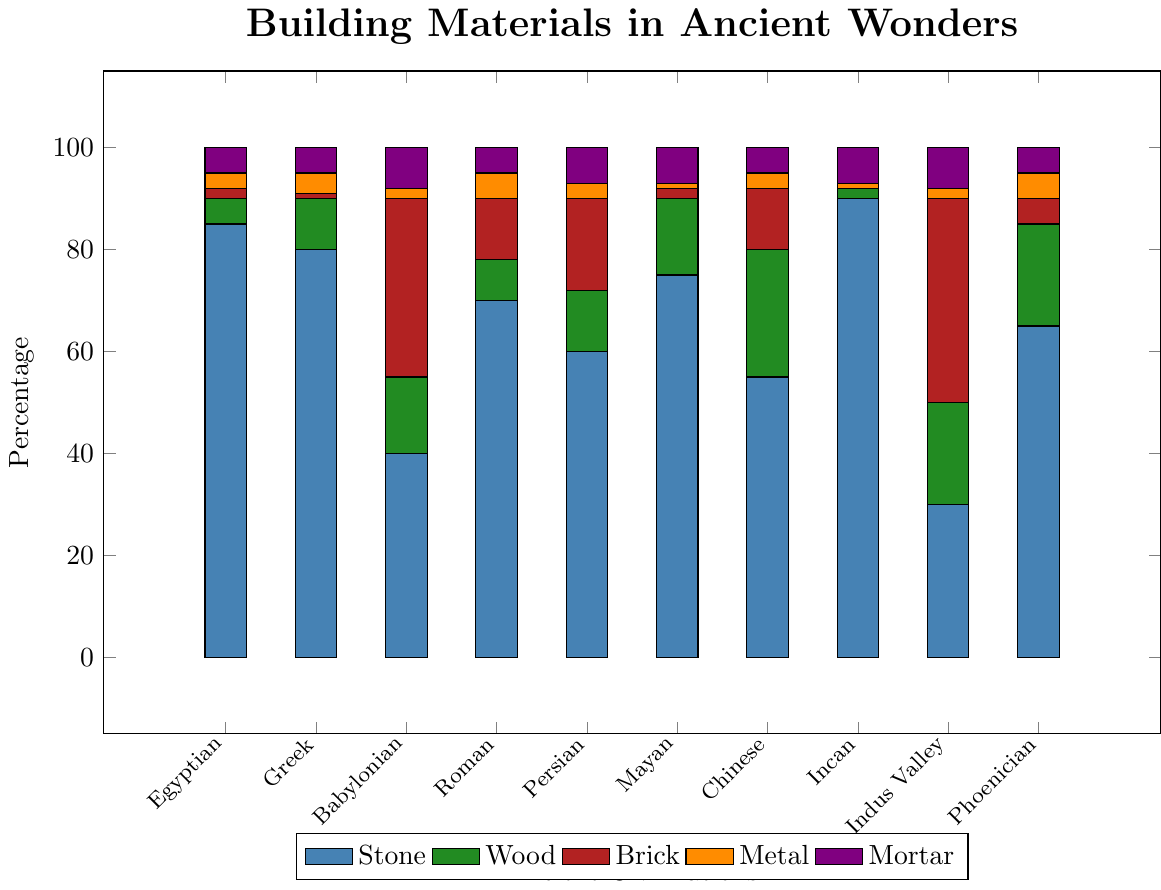Which civilization used the highest percentage of stone? The Incan civilization used the highest percentage of stone with 90%. This is seen by the tallest blue bar in the chart.
Answer: Incan Which two civilizations used the same percentage of mortar? The Ancient Egyptian and Ancient Greek civilizations both used 5% mortar. This is identified by looking for purple bars of equal height.
Answer: Ancient Egyptian, Ancient Greek By how much does the percentage of brick used by the Babylonian civilization exceed the Indus Valley civilization's wood percentage? The Babylonian civilization used 35% brick, and the Indus Valley civilization used 20% wood. The difference is 35 - 20 = 15.
Answer: 15 Compare the metal usage between Roman and Chinese civilizations. Which is higher? The Roman civilization used 5% metal, whereas the Chinese civilization used 3% metal. Thus, Roman's metal usage is higher.
Answer: Roman Which civilizations used more than 50% stone and also used wood? The civilizations that used more than 50% stone are Ancient Egyptian, Ancient Greek, Roman, Mayan, and Incan. Among these, Ancient Greek, Roman, and Mayan also used wood.
Answer: Ancient Greek, Roman, Mayan Which civilization has a higher combined percentage for wood and brick: Persian or Chinese? The Persian civilization has 12% wood and 18% brick, making a total of 12 + 18 = 30%. The Chinese civilization has 25% wood and 12% brick, making a total of 25 + 12 = 37%. The Chinese civilization has the higher combined percentage.
Answer: Chinese What is the total percentage of materials used other than stone by the Mayan civilization? The materials other than stone for the Mayan civilization are wood, brick, metal, and mortar with percentages of 15, 2, 1, and 7 respectively. Summing these gives 15 + 2 + 1 + 7 = 25%.
Answer: 25% If you average the stone usage of the Roman, Babylonian, and Persian civilizations, what percentage do you get? The stone usage percentages are Roman: 70%, Babylonian: 40%, and Persian: 60%. The average is (70 + 40 + 60) / 3 = 170 / 3 ≈ 56.67%.
Answer: 56.67% Which civilization used the least wood, and what percentage did they use? The civilization that used the least wood is the Incan civilization with 2%. This can be determined by identifying the shortest green bar.
Answer: Incan, 2% 